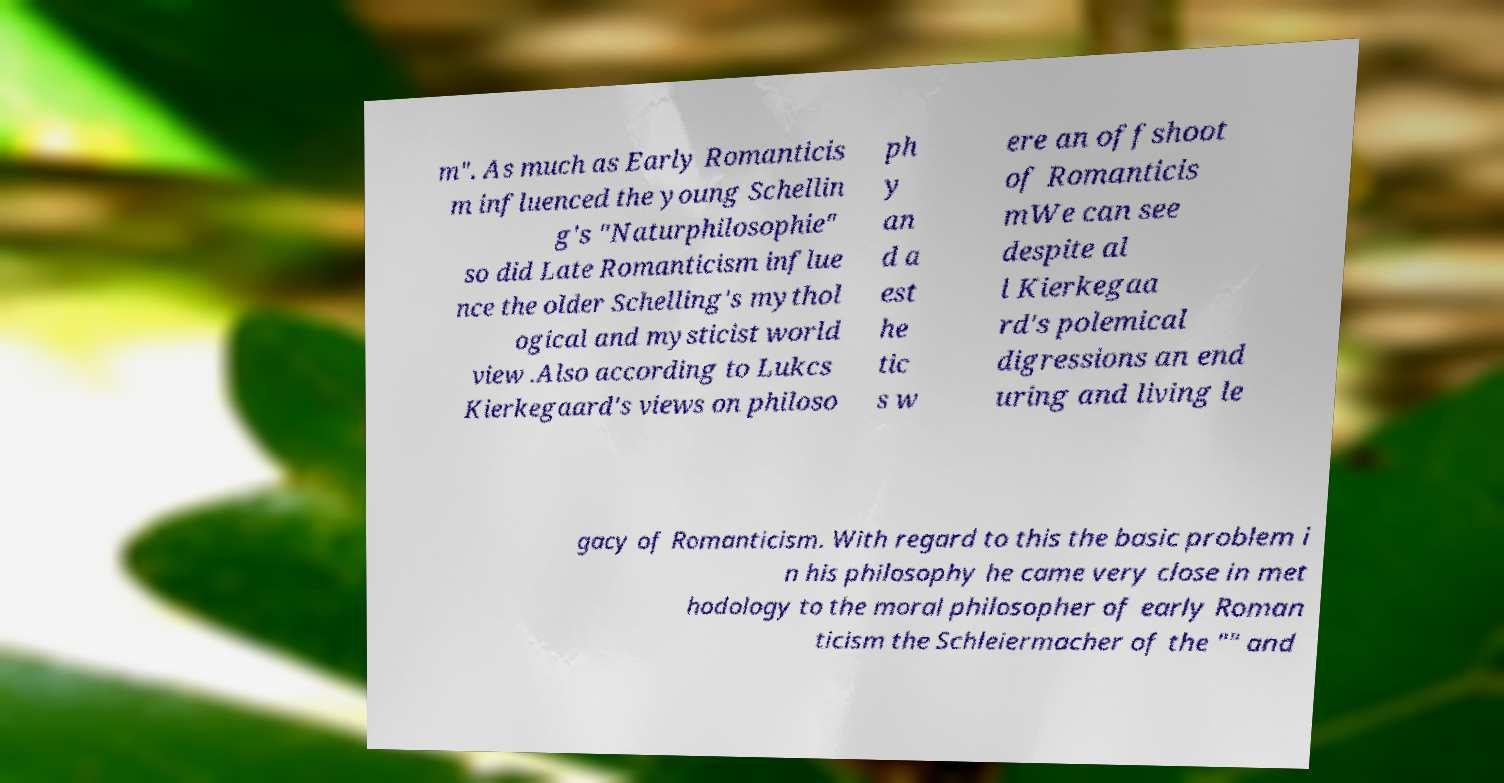I need the written content from this picture converted into text. Can you do that? m". As much as Early Romanticis m influenced the young Schellin g's "Naturphilosophie" so did Late Romanticism influe nce the older Schelling's mythol ogical and mysticist world view .Also according to Lukcs Kierkegaard's views on philoso ph y an d a est he tic s w ere an offshoot of Romanticis mWe can see despite al l Kierkegaa rd's polemical digressions an end uring and living le gacy of Romanticism. With regard to this the basic problem i n his philosophy he came very close in met hodology to the moral philosopher of early Roman ticism the Schleiermacher of the "" and 